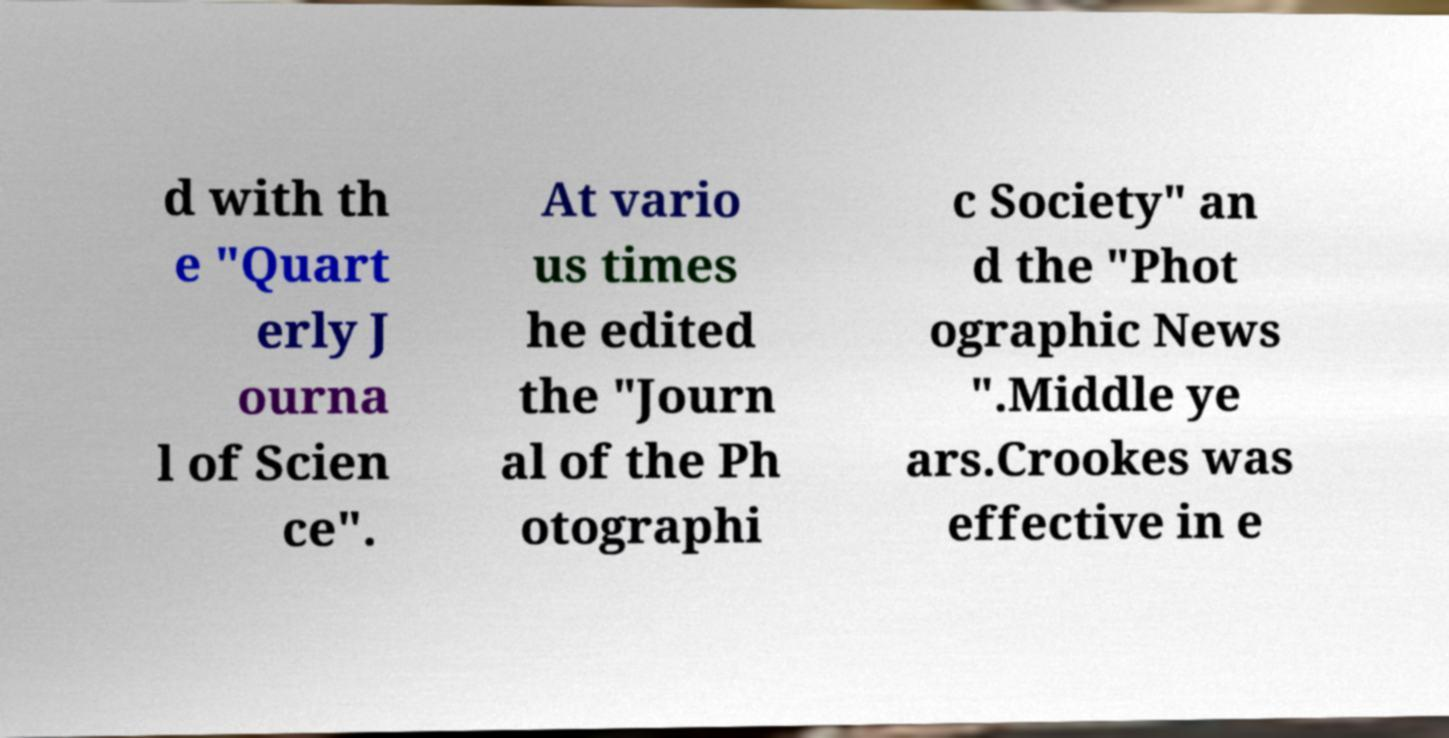For documentation purposes, I need the text within this image transcribed. Could you provide that? d with th e "Quart erly J ourna l of Scien ce". At vario us times he edited the "Journ al of the Ph otographi c Society" an d the "Phot ographic News ".Middle ye ars.Crookes was effective in e 